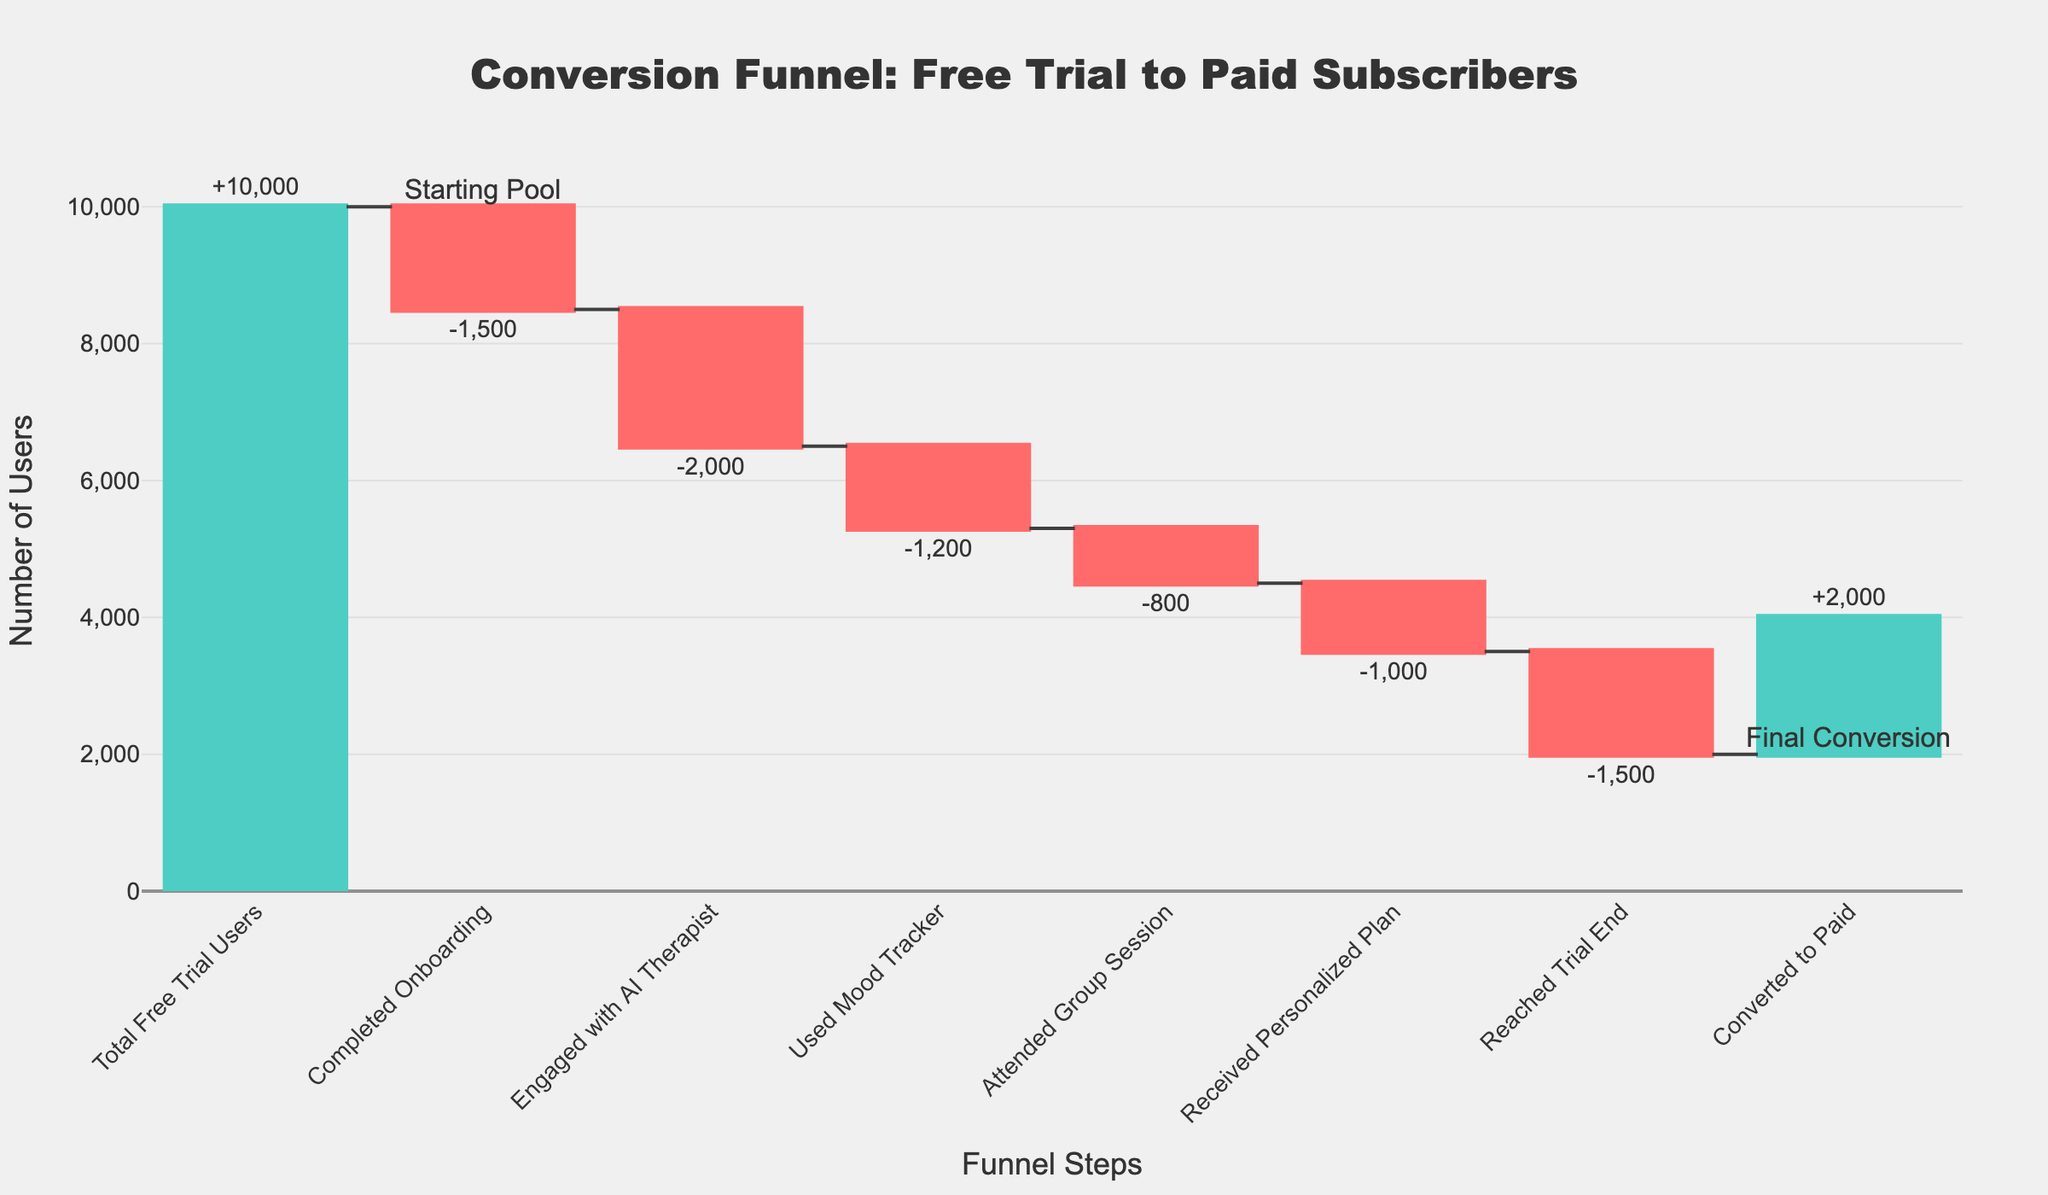What's the total number of free trial users? The total number of free trial users is indicated at the beginning of the chart under "Total Free Trial Users".
Answer: 10,000 How many users completed onboarding? The decrease in users after completing onboarding is shown as -1,500.
Answer: 1,500 What is the number of users who converted to paid subscribers? The final value on the chart, next to "Converted to Paid", shows this number as +2,000.
Answer: 2,000 How many users did not engage with the AI Therapist? The change in users due to not engaging with the AI Therapist is shown as -2,000.
Answer: 2,000 What is the net change in users from the starting point to the final conversion? The chart starts with 10,000 users and ends with 2,000 users converting to paid subscribers. The net change is \(10,000 - 2,000 = 8,000\) users lost.
Answer: 8,000 Which step has the highest number of users lost apart from the initial and final steps? The step "Engaged with AI Therapist" shows the largest decrease of -2,000 users.
Answer: Engaged with AI Therapist What's the cumulative number of users who left before reaching the trial end? Sum the losses: -1,500 (Onboarding) + -2,000 (AI Therapist) + -1,200 (Mood Tracker) + -800 (Group Session) + -1,000 (Personalized Plan) = -6,500 users
Answer: 6,500 What percentage of the total free trial users converted to paid subscribers? Divide the number of users who converted by the total free trial users and multiply by 100: \((2,000 / 10,000) * 100 = 20\%\).
Answer: 20% How does the number of users completing onboarding compare to those attending group sessions? After onboarding, 1,500 users were lost while 800 were lost after attending group sessions. 1,500 is greater than 800.
Answer: More users were lost after onboarding How many steps resulted in a decrease in user count? Five steps (Onboarding, AI Therapist, Mood Tracker, Group Session, Personalized Plan) resulted in a loss of users.
Answer: Five steps 